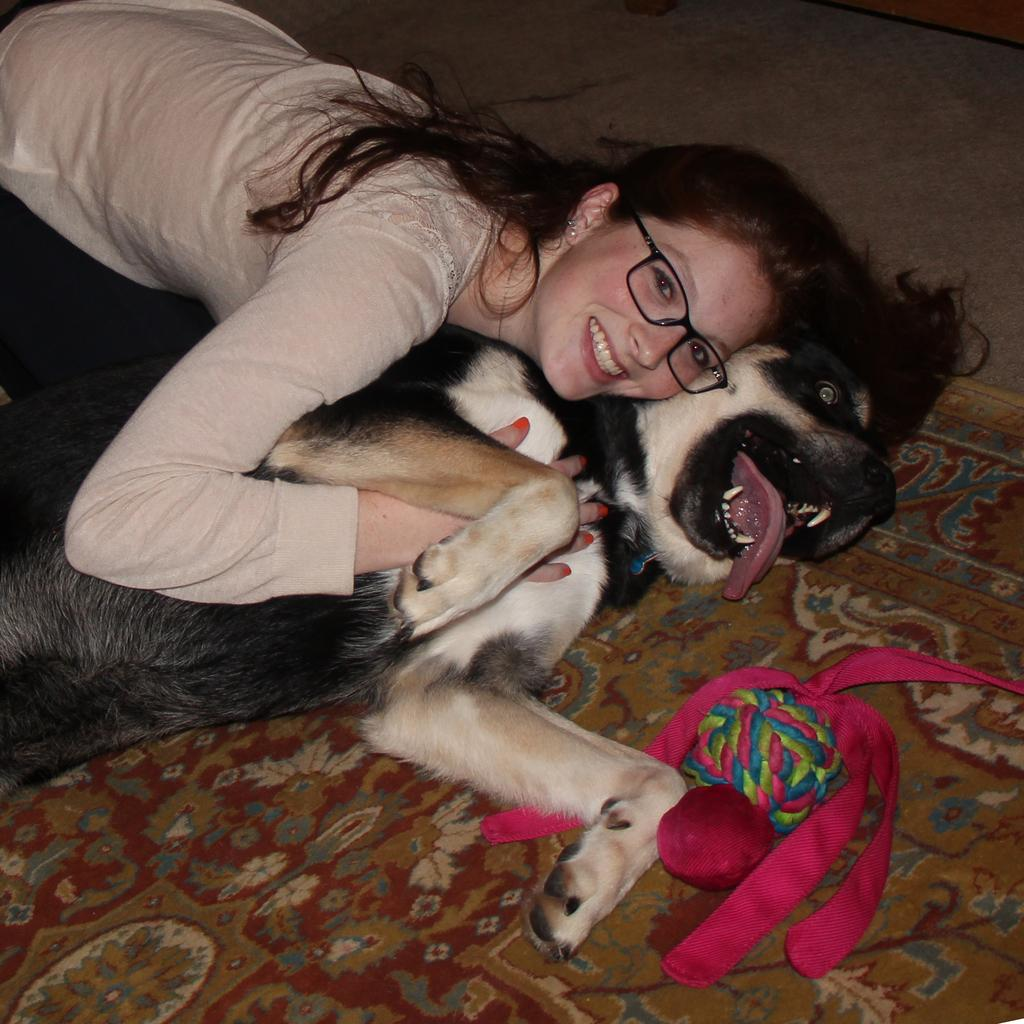Who or what is the main subject in the image? There is a person in the image. What is the person doing in the image? The person is on a dog. Where is the dog located in the image? The dog is on a carpet. What is the person wearing in the image? The person is wearing clothes and spectacles. Can you describe the object in the bottom right of the image? Unfortunately, the provided facts do not give any information about the object in the bottom right of the image. How many apples can be seen on the trip in the image? There is no trip or apples present in the image. Is there a flower in the image? The provided facts do not mention the presence of a flower in the image. 